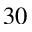Convert formula to latex. <formula><loc_0><loc_0><loc_500><loc_500>^ { 3 0 }</formula> 